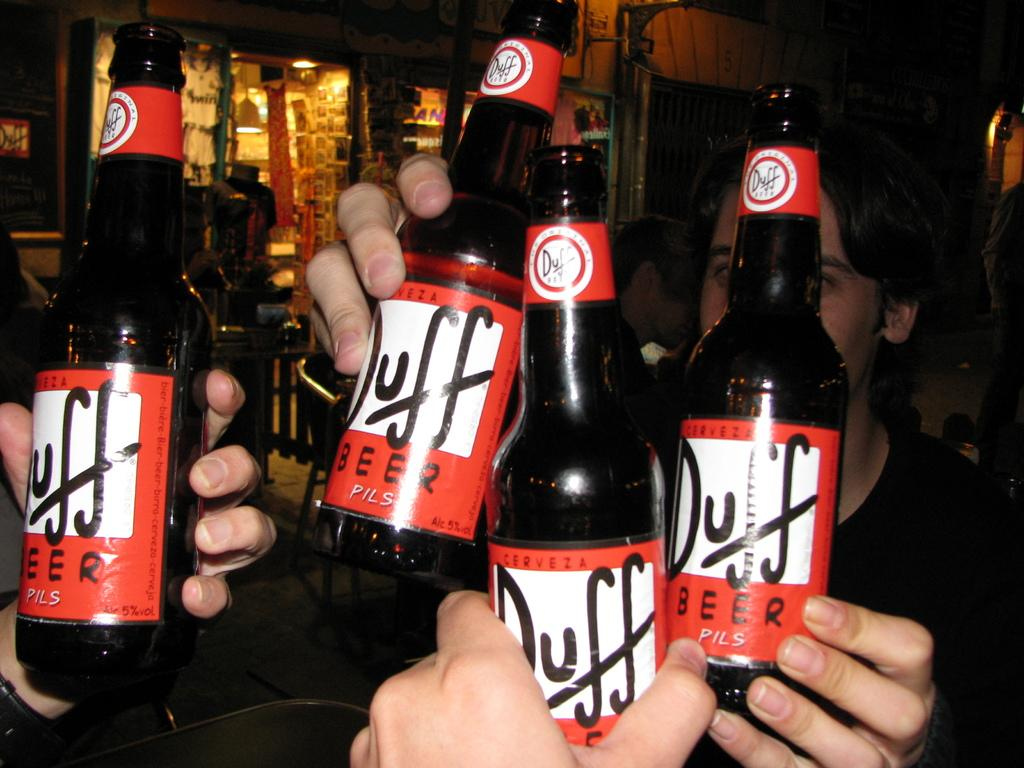<image>
Render a clear and concise summary of the photo. Bottles of Duff are raised in a few hands at a bar. 